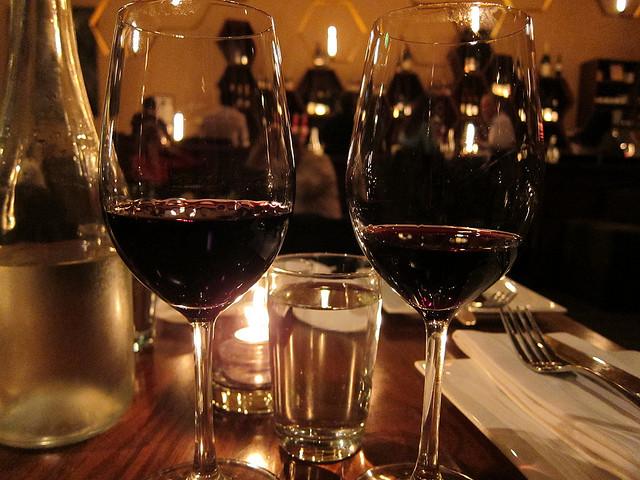What is in the glasses?
Answer briefly. Wine. What is making the light around the room?
Keep it brief. Lamps. Is the beverage in the decanter cold?
Answer briefly. Yes. 